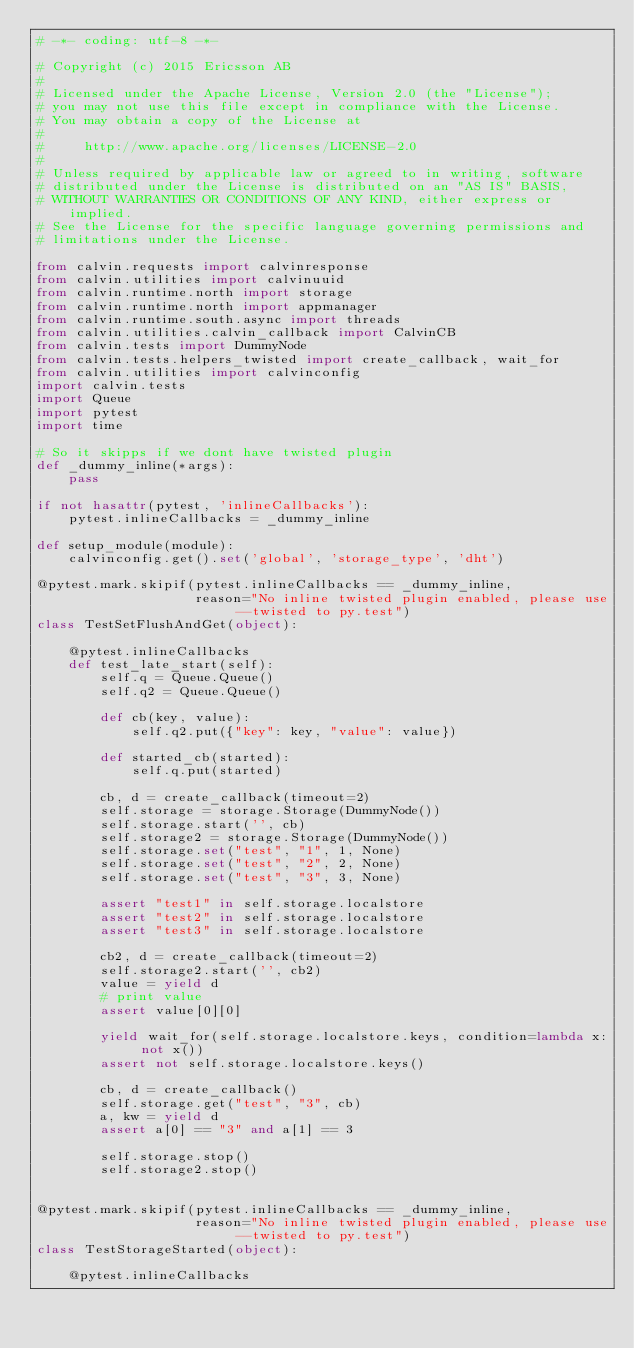<code> <loc_0><loc_0><loc_500><loc_500><_Python_># -*- coding: utf-8 -*-

# Copyright (c) 2015 Ericsson AB
#
# Licensed under the Apache License, Version 2.0 (the "License");
# you may not use this file except in compliance with the License.
# You may obtain a copy of the License at
#
#     http://www.apache.org/licenses/LICENSE-2.0
#
# Unless required by applicable law or agreed to in writing, software
# distributed under the License is distributed on an "AS IS" BASIS,
# WITHOUT WARRANTIES OR CONDITIONS OF ANY KIND, either express or implied.
# See the License for the specific language governing permissions and
# limitations under the License.

from calvin.requests import calvinresponse
from calvin.utilities import calvinuuid
from calvin.runtime.north import storage
from calvin.runtime.north import appmanager
from calvin.runtime.south.async import threads
from calvin.utilities.calvin_callback import CalvinCB
from calvin.tests import DummyNode
from calvin.tests.helpers_twisted import create_callback, wait_for
from calvin.utilities import calvinconfig
import calvin.tests
import Queue
import pytest
import time

# So it skipps if we dont have twisted plugin
def _dummy_inline(*args):
    pass

if not hasattr(pytest, 'inlineCallbacks'):
    pytest.inlineCallbacks = _dummy_inline

def setup_module(module):
    calvinconfig.get().set('global', 'storage_type', 'dht')

@pytest.mark.skipif(pytest.inlineCallbacks == _dummy_inline,
                    reason="No inline twisted plugin enabled, please use --twisted to py.test")
class TestSetFlushAndGet(object):

    @pytest.inlineCallbacks
    def test_late_start(self):
        self.q = Queue.Queue()
        self.q2 = Queue.Queue()

        def cb(key, value):
            self.q2.put({"key": key, "value": value})

        def started_cb(started):
            self.q.put(started)

        cb, d = create_callback(timeout=2)
        self.storage = storage.Storage(DummyNode())
        self.storage.start('', cb)
        self.storage2 = storage.Storage(DummyNode())
        self.storage.set("test", "1", 1, None)
        self.storage.set("test", "2", 2, None)
        self.storage.set("test", "3", 3, None)

        assert "test1" in self.storage.localstore
        assert "test2" in self.storage.localstore
        assert "test3" in self.storage.localstore

        cb2, d = create_callback(timeout=2)
        self.storage2.start('', cb2)
        value = yield d
        # print value
        assert value[0][0]

        yield wait_for(self.storage.localstore.keys, condition=lambda x: not x())
        assert not self.storage.localstore.keys()

        cb, d = create_callback()
        self.storage.get("test", "3", cb)
        a, kw = yield d
        assert a[0] == "3" and a[1] == 3

        self.storage.stop()
        self.storage2.stop()


@pytest.mark.skipif(pytest.inlineCallbacks == _dummy_inline,
                    reason="No inline twisted plugin enabled, please use --twisted to py.test")
class TestStorageStarted(object):

    @pytest.inlineCallbacks</code> 